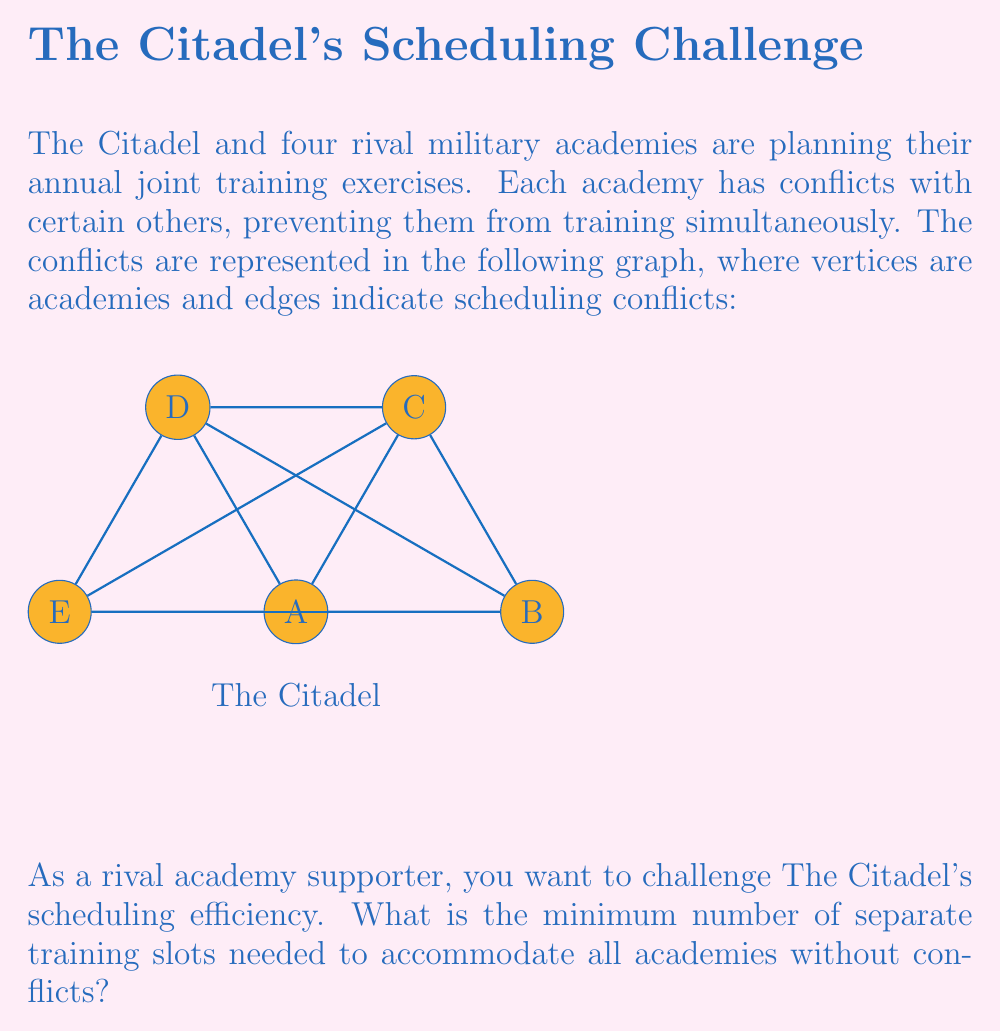Show me your answer to this math problem. To solve this problem, we need to find the chromatic number of the given graph. The chromatic number is the minimum number of colors needed to color the vertices of a graph such that no two adjacent vertices share the same color. In this case, colors represent training slots.

Let's approach this step-by-step:

1) First, observe that the graph is a complete graph $K_5$ (all vertices are connected to each other), except for the missing edge between vertices C and D.

2) For a complete graph $K_n$, the chromatic number is always $n$. However, our graph is $K_5$ minus one edge, so its chromatic number might be 4 or 5.

3) Let's attempt to color the graph with 4 colors:
   - Assign color 1 to vertex A (The Citadel)
   - Assign color 2 to vertex B
   - Assign color 3 to vertex E
   - Assign color 4 to vertex C
   - Now, we're left with vertex D. It's connected to A, B, and E, which use colors 1, 2, and 3. But D is not connected to C, so we can use color 4 for D.

4) This coloring works, using only 4 colors. Therefore, the chromatic number of this graph is 4.

5) In terms of scheduling, this means we need a minimum of 4 separate training slots to accommodate all academies without conflicts.

This result challenges The Citadel's efficiency, as they require 4 slots despite having only 5 academies, due to the numerous conflicts in their schedule.
Answer: 4 